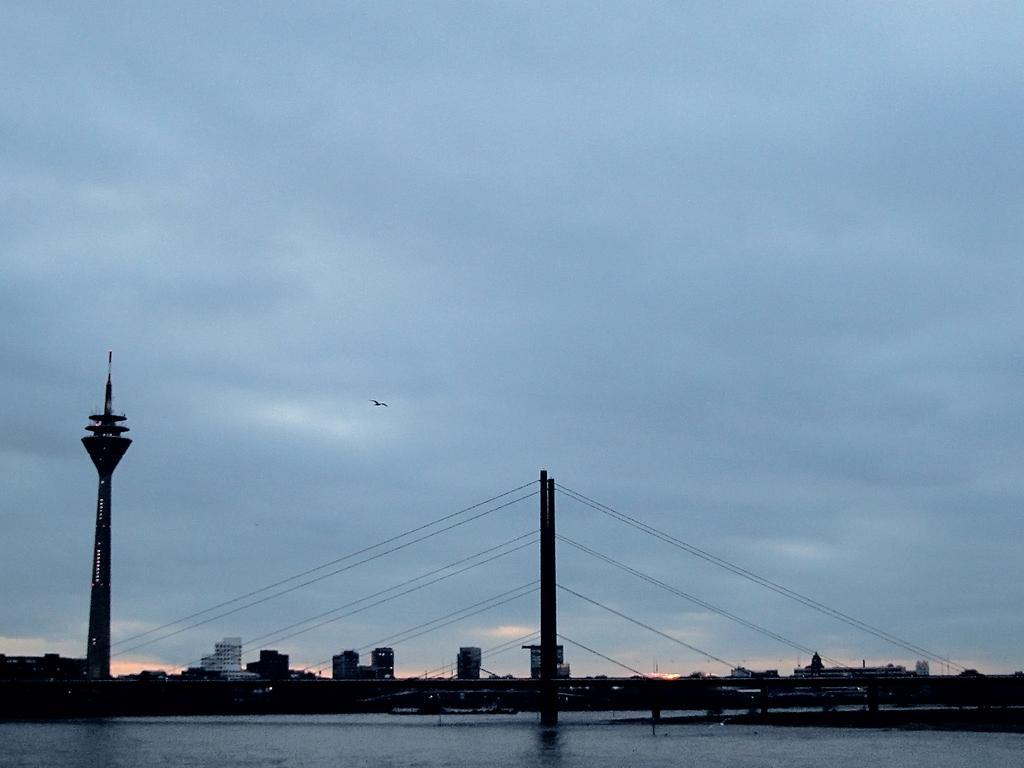What structure is the main subject of the image? There is a bridge in the image. What is the bridge positioned over? The bridge is over a river. What other structures can be seen near the bridge? There is a tower near the bridge. What can be seen in the background of the image? There are buildings and trees in the background of the image. What is visible in the sky in the image? There is a bird visible in the sky, and there are clouds in the sky. What type of grass is growing on the bridge in the image? There is no grass growing on the bridge in the image. 